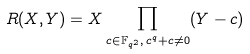<formula> <loc_0><loc_0><loc_500><loc_500>R ( X , Y ) = X \prod _ { c \in \mathbb { F } _ { q ^ { 2 } } , \, c ^ { q } + c \neq 0 } ( Y - c )</formula> 